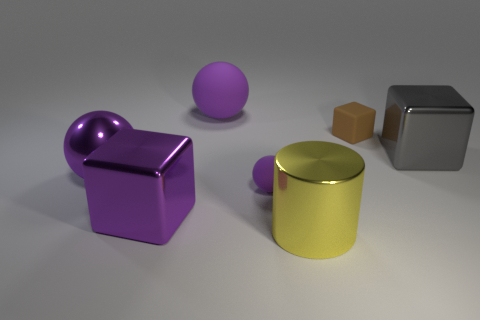How many purple spheres must be subtracted to get 2 purple spheres? 1 Add 1 blue metallic blocks. How many objects exist? 8 Subtract all cylinders. How many objects are left? 6 Subtract 1 cylinders. How many cylinders are left? 0 Subtract all blue cubes. Subtract all cyan spheres. How many cubes are left? 3 Subtract all green cylinders. How many yellow blocks are left? 0 Subtract all large metal cubes. Subtract all big purple spheres. How many objects are left? 3 Add 4 shiny cylinders. How many shiny cylinders are left? 5 Add 6 big shiny things. How many big shiny things exist? 10 Subtract all brown blocks. How many blocks are left? 2 